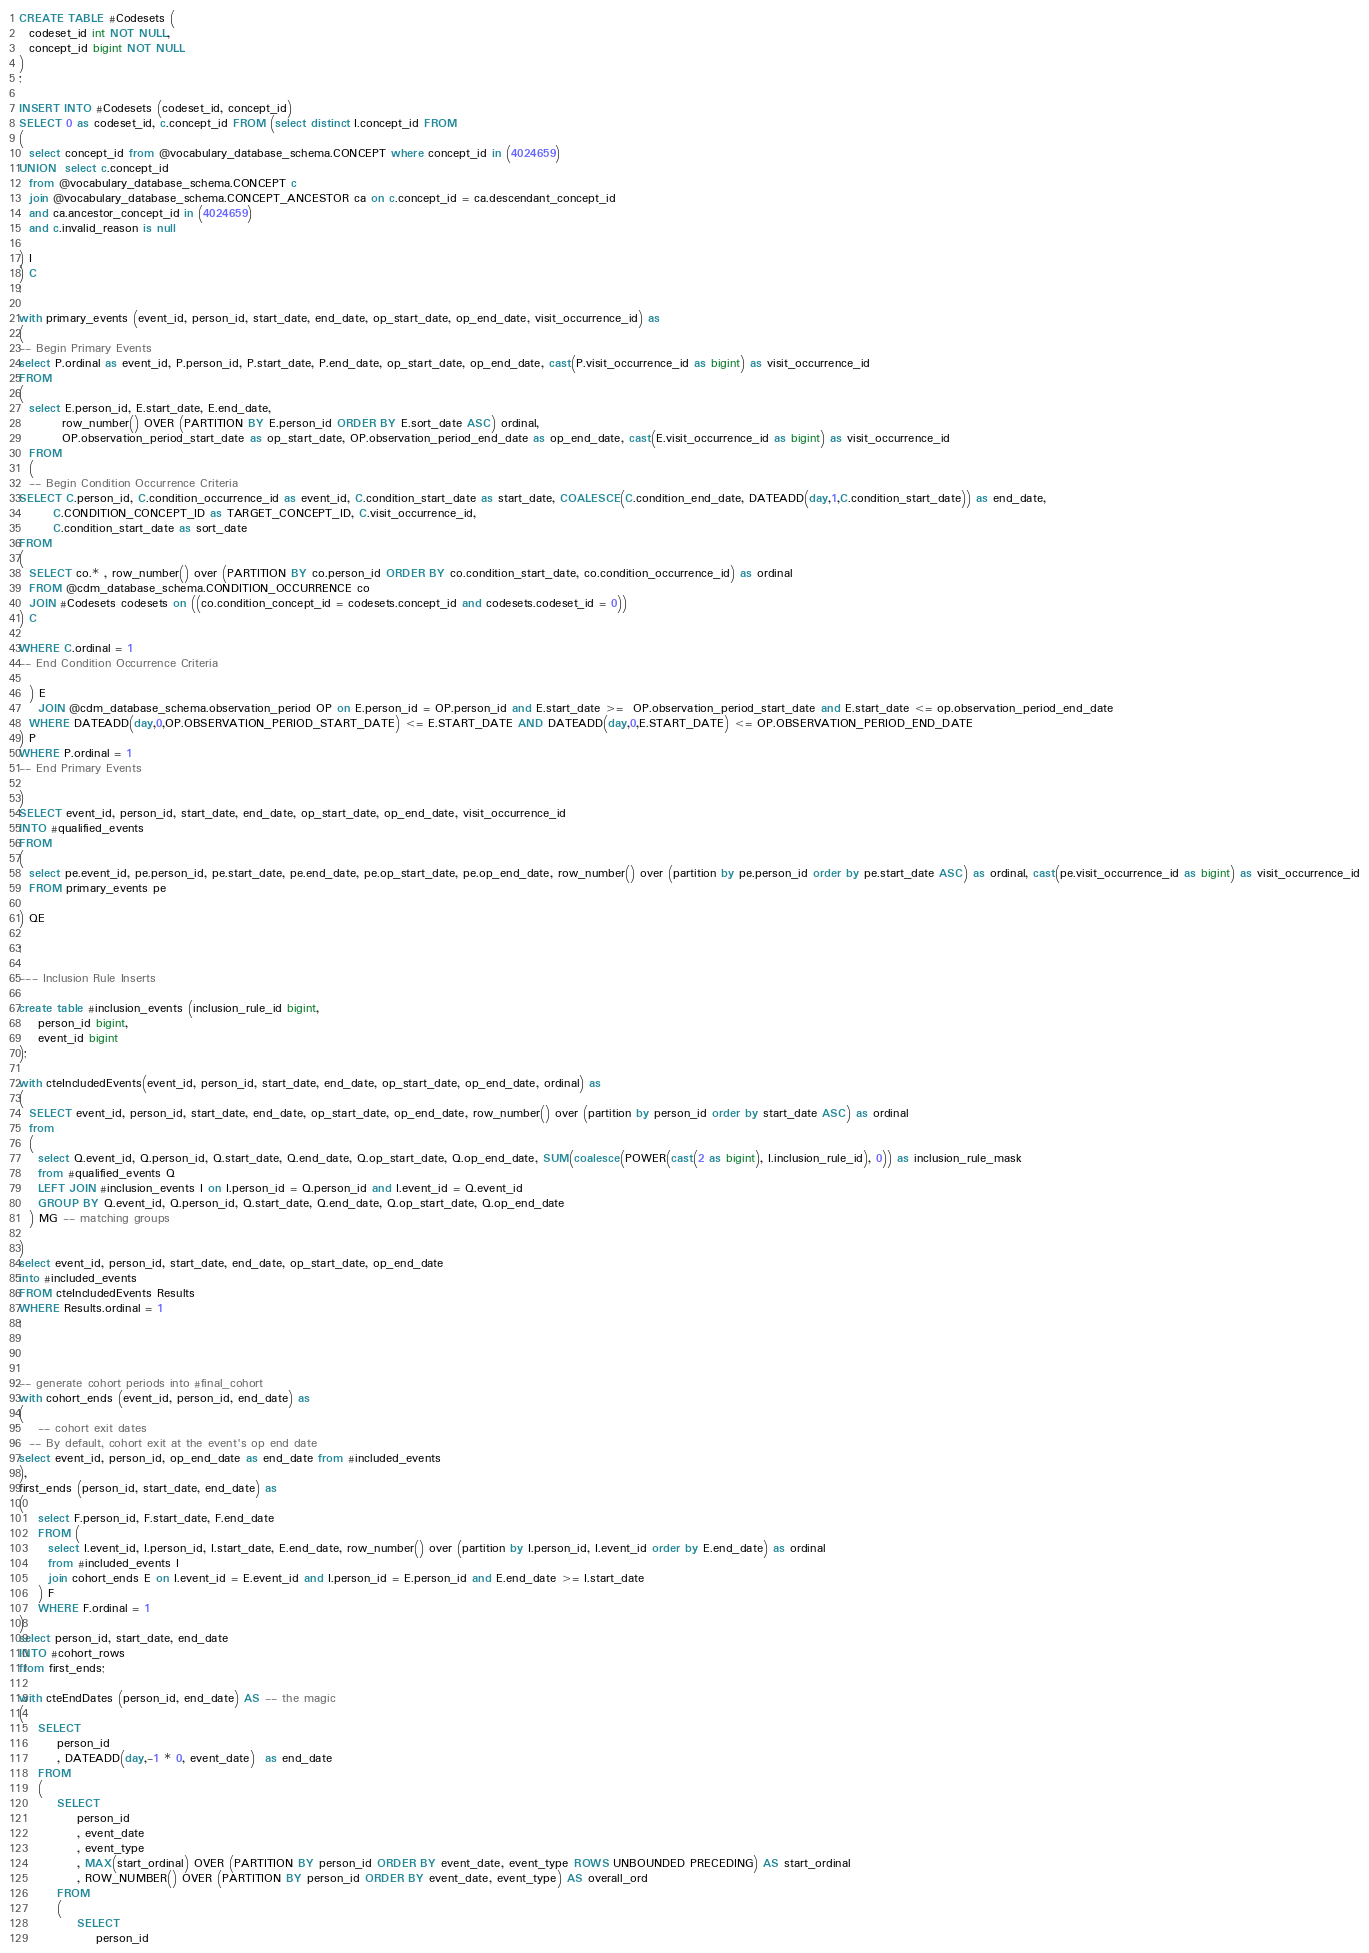Convert code to text. <code><loc_0><loc_0><loc_500><loc_500><_SQL_>CREATE TABLE #Codesets (
  codeset_id int NOT NULL,
  concept_id bigint NOT NULL
)
;

INSERT INTO #Codesets (codeset_id, concept_id)
SELECT 0 as codeset_id, c.concept_id FROM (select distinct I.concept_id FROM
( 
  select concept_id from @vocabulary_database_schema.CONCEPT where concept_id in (4024659)
UNION  select c.concept_id
  from @vocabulary_database_schema.CONCEPT c
  join @vocabulary_database_schema.CONCEPT_ANCESTOR ca on c.concept_id = ca.descendant_concept_id
  and ca.ancestor_concept_id in (4024659)
  and c.invalid_reason is null

) I
) C
;

with primary_events (event_id, person_id, start_date, end_date, op_start_date, op_end_date, visit_occurrence_id) as
(
-- Begin Primary Events
select P.ordinal as event_id, P.person_id, P.start_date, P.end_date, op_start_date, op_end_date, cast(P.visit_occurrence_id as bigint) as visit_occurrence_id
FROM
(
  select E.person_id, E.start_date, E.end_date,
         row_number() OVER (PARTITION BY E.person_id ORDER BY E.sort_date ASC) ordinal,
         OP.observation_period_start_date as op_start_date, OP.observation_period_end_date as op_end_date, cast(E.visit_occurrence_id as bigint) as visit_occurrence_id
  FROM 
  (
  -- Begin Condition Occurrence Criteria
SELECT C.person_id, C.condition_occurrence_id as event_id, C.condition_start_date as start_date, COALESCE(C.condition_end_date, DATEADD(day,1,C.condition_start_date)) as end_date,
       C.CONDITION_CONCEPT_ID as TARGET_CONCEPT_ID, C.visit_occurrence_id,
       C.condition_start_date as sort_date
FROM 
(
  SELECT co.* , row_number() over (PARTITION BY co.person_id ORDER BY co.condition_start_date, co.condition_occurrence_id) as ordinal
  FROM @cdm_database_schema.CONDITION_OCCURRENCE co
  JOIN #Codesets codesets on ((co.condition_concept_id = codesets.concept_id and codesets.codeset_id = 0))
) C

WHERE C.ordinal = 1
-- End Condition Occurrence Criteria

  ) E
	JOIN @cdm_database_schema.observation_period OP on E.person_id = OP.person_id and E.start_date >=  OP.observation_period_start_date and E.start_date <= op.observation_period_end_date
  WHERE DATEADD(day,0,OP.OBSERVATION_PERIOD_START_DATE) <= E.START_DATE AND DATEADD(day,0,E.START_DATE) <= OP.OBSERVATION_PERIOD_END_DATE
) P
WHERE P.ordinal = 1
-- End Primary Events

)
SELECT event_id, person_id, start_date, end_date, op_start_date, op_end_date, visit_occurrence_id
INTO #qualified_events
FROM 
(
  select pe.event_id, pe.person_id, pe.start_date, pe.end_date, pe.op_start_date, pe.op_end_date, row_number() over (partition by pe.person_id order by pe.start_date ASC) as ordinal, cast(pe.visit_occurrence_id as bigint) as visit_occurrence_id
  FROM primary_events pe
  
) QE

;

--- Inclusion Rule Inserts

create table #inclusion_events (inclusion_rule_id bigint,
	person_id bigint,
	event_id bigint
);

with cteIncludedEvents(event_id, person_id, start_date, end_date, op_start_date, op_end_date, ordinal) as
(
  SELECT event_id, person_id, start_date, end_date, op_start_date, op_end_date, row_number() over (partition by person_id order by start_date ASC) as ordinal
  from
  (
    select Q.event_id, Q.person_id, Q.start_date, Q.end_date, Q.op_start_date, Q.op_end_date, SUM(coalesce(POWER(cast(2 as bigint), I.inclusion_rule_id), 0)) as inclusion_rule_mask
    from #qualified_events Q
    LEFT JOIN #inclusion_events I on I.person_id = Q.person_id and I.event_id = Q.event_id
    GROUP BY Q.event_id, Q.person_id, Q.start_date, Q.end_date, Q.op_start_date, Q.op_end_date
  ) MG -- matching groups

)
select event_id, person_id, start_date, end_date, op_start_date, op_end_date
into #included_events
FROM cteIncludedEvents Results
WHERE Results.ordinal = 1
;



-- generate cohort periods into #final_cohort
with cohort_ends (event_id, person_id, end_date) as
(
	-- cohort exit dates
  -- By default, cohort exit at the event's op end date
select event_id, person_id, op_end_date as end_date from #included_events
),
first_ends (person_id, start_date, end_date) as
(
	select F.person_id, F.start_date, F.end_date
	FROM (
	  select I.event_id, I.person_id, I.start_date, E.end_date, row_number() over (partition by I.person_id, I.event_id order by E.end_date) as ordinal 
	  from #included_events I
	  join cohort_ends E on I.event_id = E.event_id and I.person_id = E.person_id and E.end_date >= I.start_date
	) F
	WHERE F.ordinal = 1
)
select person_id, start_date, end_date
INTO #cohort_rows
from first_ends;

with cteEndDates (person_id, end_date) AS -- the magic
(	
	SELECT
		person_id
		, DATEADD(day,-1 * 0, event_date)  as end_date
	FROM
	(
		SELECT
			person_id
			, event_date
			, event_type
			, MAX(start_ordinal) OVER (PARTITION BY person_id ORDER BY event_date, event_type ROWS UNBOUNDED PRECEDING) AS start_ordinal 
			, ROW_NUMBER() OVER (PARTITION BY person_id ORDER BY event_date, event_type) AS overall_ord
		FROM
		(
			SELECT
				person_id</code> 